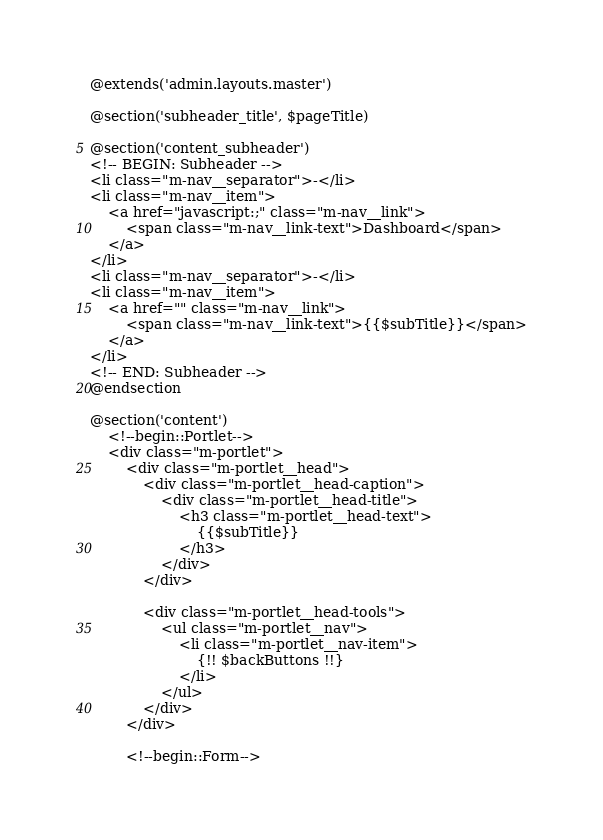<code> <loc_0><loc_0><loc_500><loc_500><_PHP_>@extends('admin.layouts.master')

@section('subheader_title', $pageTitle)

@section('content_subheader')
<!-- BEGIN: Subheader -->
<li class="m-nav__separator">-</li>
<li class="m-nav__item">
    <a href="javascript:;" class="m-nav__link">
        <span class="m-nav__link-text">Dashboard</span>
    </a>
</li>
<li class="m-nav__separator">-</li>
<li class="m-nav__item">
    <a href="" class="m-nav__link">
        <span class="m-nav__link-text">{{$subTitle}}</span>
    </a>
</li>
<!-- END: Subheader -->
@endsection

@section('content')
    <!--begin::Portlet-->
    <div class="m-portlet">
        <div class="m-portlet__head">
            <div class="m-portlet__head-caption">
                <div class="m-portlet__head-title">
                    <h3 class="m-portlet__head-text">
                        {{$subTitle}}
                    </h3>
                </div>
            </div>

            <div class="m-portlet__head-tools">
                <ul class="m-portlet__nav">
                    <li class="m-portlet__nav-item">
                        {!! $backButtons !!}
                    </li>
                </ul>
            </div>
        </div>

        <!--begin::Form--></code> 